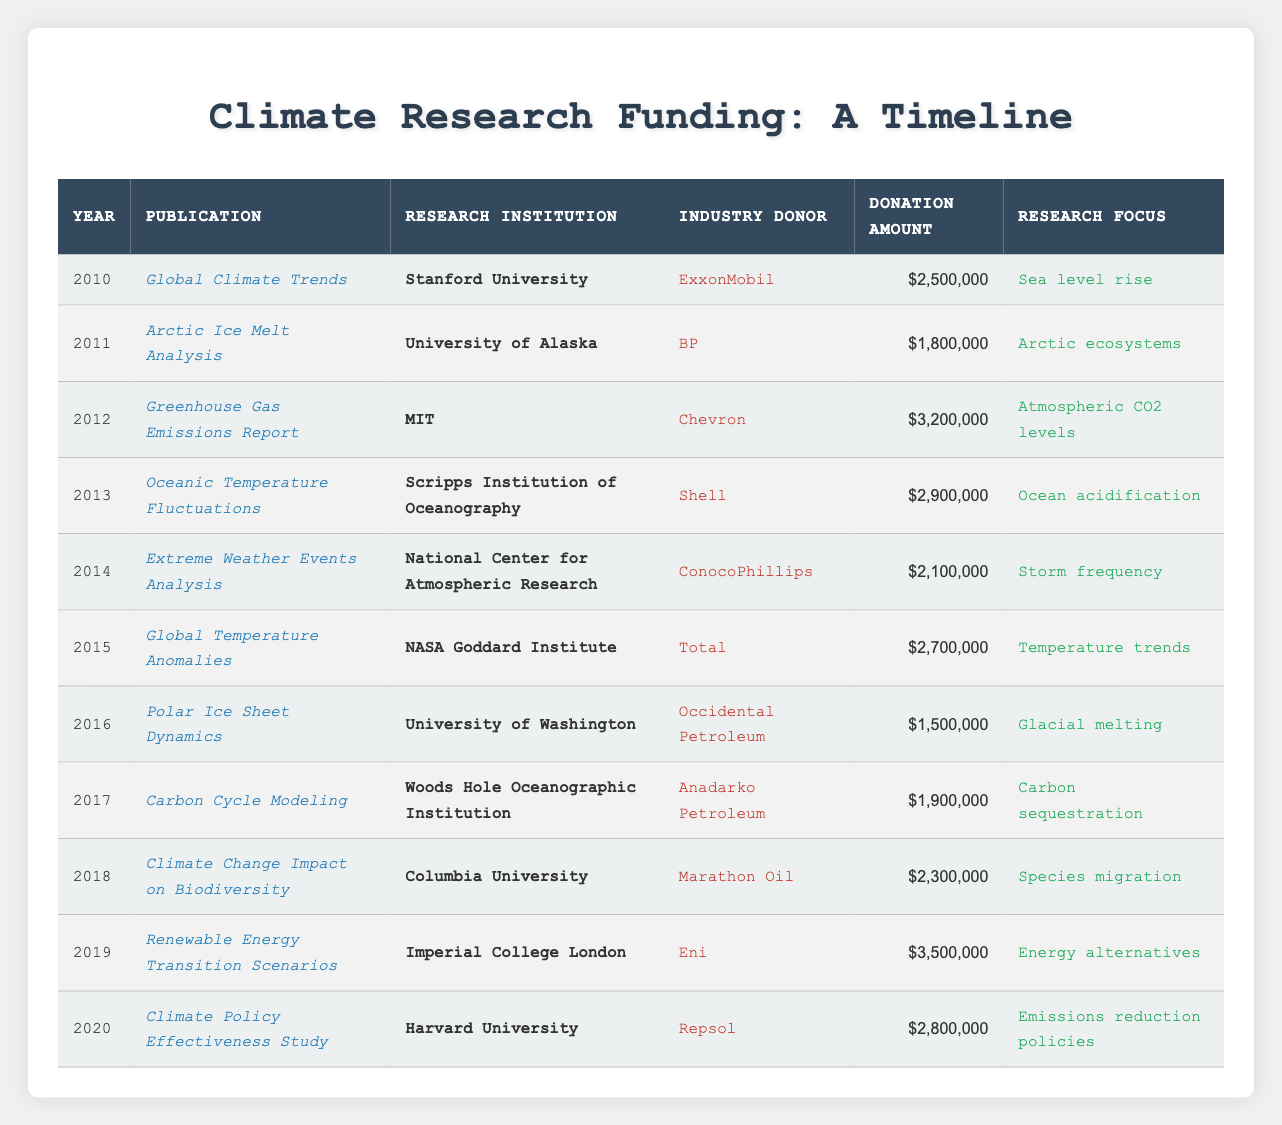What publication received the highest donation? The table contains a column for "Donation Amount." By observing the values, we note that "Renewable Energy Transition Scenarios," published in 2019, received the highest donation of $3,500,000.
Answer: Renewable Energy Transition Scenarios Which research institution conducted the study on sea level rise? The "Global Climate Trends" publication in 2010, which focuses on sea level rise, lists Stanford University as the research institution.
Answer: Stanford University How much total funding was donated to climate research from 2010 to 2020? To find the total funding, we need to sum all the donation amounts: $2,500,000 + $1,800,000 + $3,200,000 + $2,900,000 + $2,100,000 + $2,700,000 + $1,500,000 + $1,900,000 + $2,300,000 + $3,500,000 + $2,800,000 = $27,700,000.
Answer: $27,700,000 Did ConocoPhillips fund any research related to Arctic ecosystems? Checking the table, ConocoPhillips donated $2,100,000 for the "Extreme Weather Events Analysis" in 2014, which does not relate to Arctic ecosystems. Therefore, the answer is no.
Answer: No Which industry donor contributed to the highest number of publications? By reviewing the industry donors across all publications, we note that each donor is associated with only one publication in this dataset. Thus, there is no donor that contributed to multiple publications.
Answer: None 